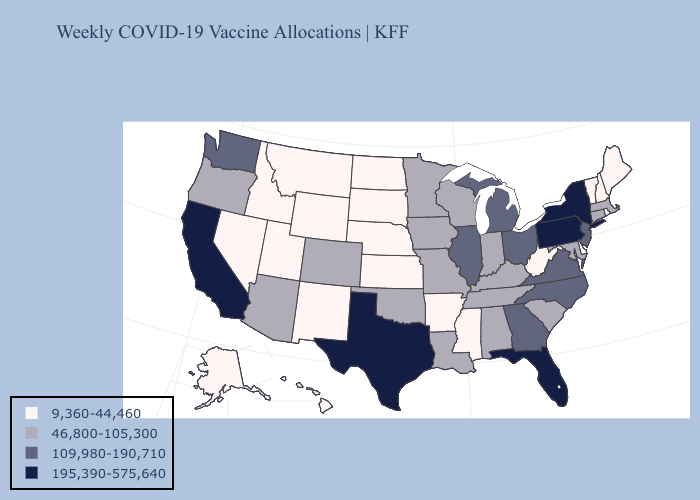Among the states that border Nebraska , does Colorado have the highest value?
Write a very short answer. Yes. What is the lowest value in states that border Kentucky?
Keep it brief. 9,360-44,460. Does the map have missing data?
Give a very brief answer. No. Does Kentucky have a lower value than Texas?
Concise answer only. Yes. What is the value of Florida?
Write a very short answer. 195,390-575,640. Does New Hampshire have the highest value in the Northeast?
Concise answer only. No. Does Arizona have a lower value than Nevada?
Keep it brief. No. What is the value of Florida?
Be succinct. 195,390-575,640. Name the states that have a value in the range 46,800-105,300?
Give a very brief answer. Alabama, Arizona, Colorado, Connecticut, Indiana, Iowa, Kentucky, Louisiana, Maryland, Massachusetts, Minnesota, Missouri, Oklahoma, Oregon, South Carolina, Tennessee, Wisconsin. Name the states that have a value in the range 195,390-575,640?
Write a very short answer. California, Florida, New York, Pennsylvania, Texas. Does Pennsylvania have the highest value in the Northeast?
Answer briefly. Yes. Name the states that have a value in the range 195,390-575,640?
Keep it brief. California, Florida, New York, Pennsylvania, Texas. How many symbols are there in the legend?
Concise answer only. 4. Among the states that border Arkansas , does Mississippi have the lowest value?
Short answer required. Yes. 